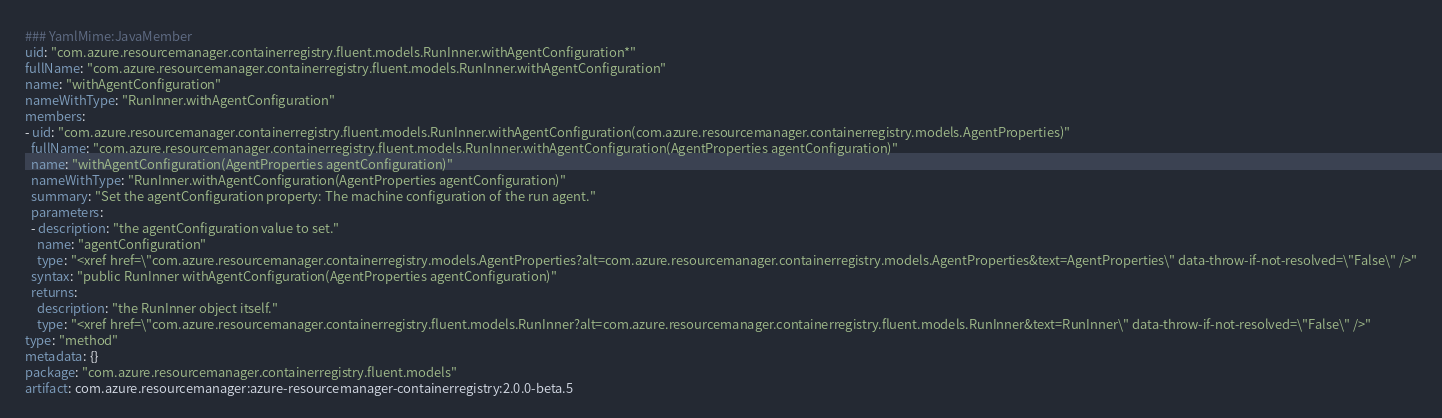Convert code to text. <code><loc_0><loc_0><loc_500><loc_500><_YAML_>### YamlMime:JavaMember
uid: "com.azure.resourcemanager.containerregistry.fluent.models.RunInner.withAgentConfiguration*"
fullName: "com.azure.resourcemanager.containerregistry.fluent.models.RunInner.withAgentConfiguration"
name: "withAgentConfiguration"
nameWithType: "RunInner.withAgentConfiguration"
members:
- uid: "com.azure.resourcemanager.containerregistry.fluent.models.RunInner.withAgentConfiguration(com.azure.resourcemanager.containerregistry.models.AgentProperties)"
  fullName: "com.azure.resourcemanager.containerregistry.fluent.models.RunInner.withAgentConfiguration(AgentProperties agentConfiguration)"
  name: "withAgentConfiguration(AgentProperties agentConfiguration)"
  nameWithType: "RunInner.withAgentConfiguration(AgentProperties agentConfiguration)"
  summary: "Set the agentConfiguration property: The machine configuration of the run agent."
  parameters:
  - description: "the agentConfiguration value to set."
    name: "agentConfiguration"
    type: "<xref href=\"com.azure.resourcemanager.containerregistry.models.AgentProperties?alt=com.azure.resourcemanager.containerregistry.models.AgentProperties&text=AgentProperties\" data-throw-if-not-resolved=\"False\" />"
  syntax: "public RunInner withAgentConfiguration(AgentProperties agentConfiguration)"
  returns:
    description: "the RunInner object itself."
    type: "<xref href=\"com.azure.resourcemanager.containerregistry.fluent.models.RunInner?alt=com.azure.resourcemanager.containerregistry.fluent.models.RunInner&text=RunInner\" data-throw-if-not-resolved=\"False\" />"
type: "method"
metadata: {}
package: "com.azure.resourcemanager.containerregistry.fluent.models"
artifact: com.azure.resourcemanager:azure-resourcemanager-containerregistry:2.0.0-beta.5
</code> 